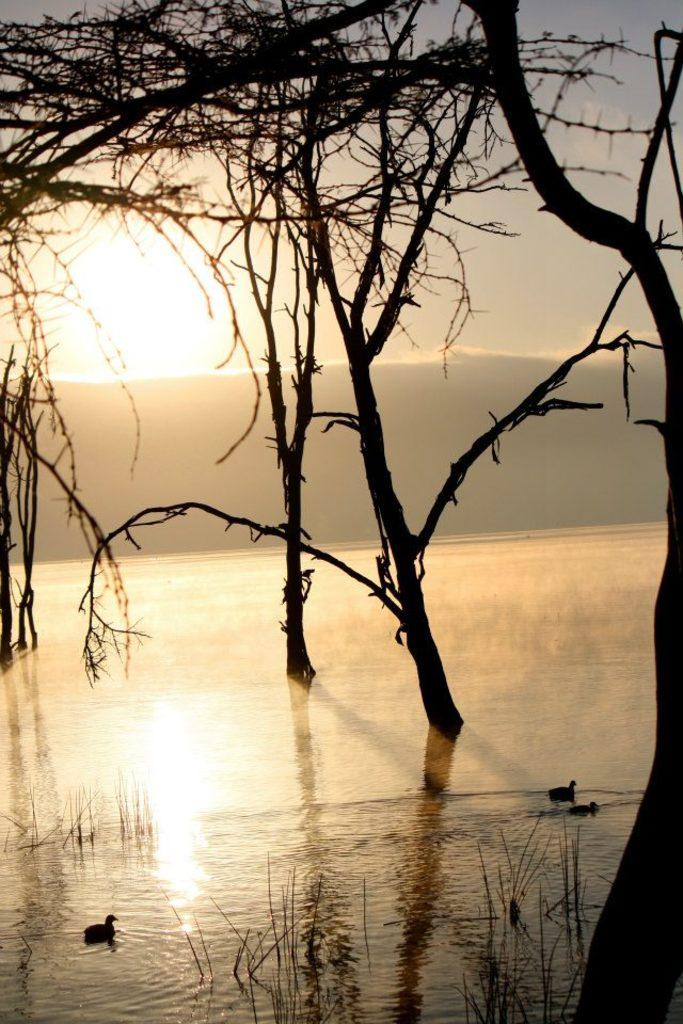What body of water is present in the image? There is a river in the picture. What animals can be seen in the water? There are ducks swimming in the water. What type of vegetation is visible in the image? There are trees visible in the picture. What geographical feature is present in the background of the image? There is a mountain in the backdrop of the image. What is the weather like in the image? The sky is clear and sunny in the image. What type of wine is being served at the team's observation event in the image? There is no team, observation event, or wine present in the image; it features a river, ducks, trees, a mountain, and a clear, sunny sky. 